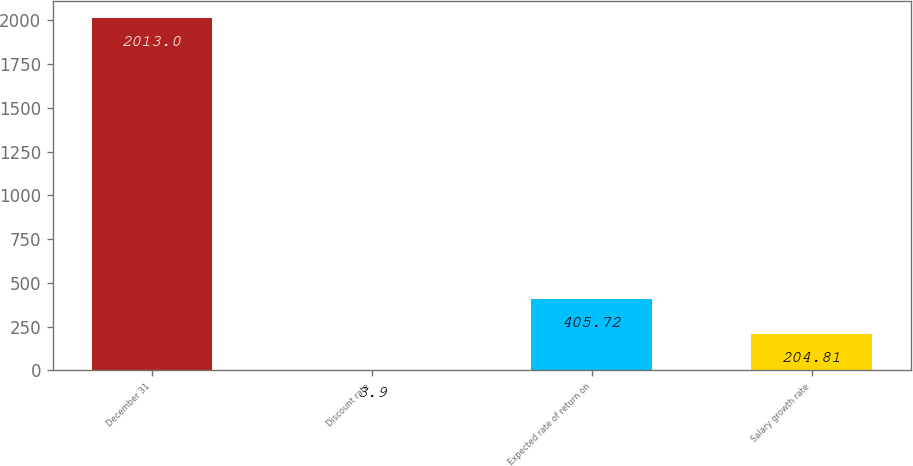Convert chart. <chart><loc_0><loc_0><loc_500><loc_500><bar_chart><fcel>December 31<fcel>Discount rate<fcel>Expected rate of return on<fcel>Salary growth rate<nl><fcel>2013<fcel>3.9<fcel>405.72<fcel>204.81<nl></chart> 